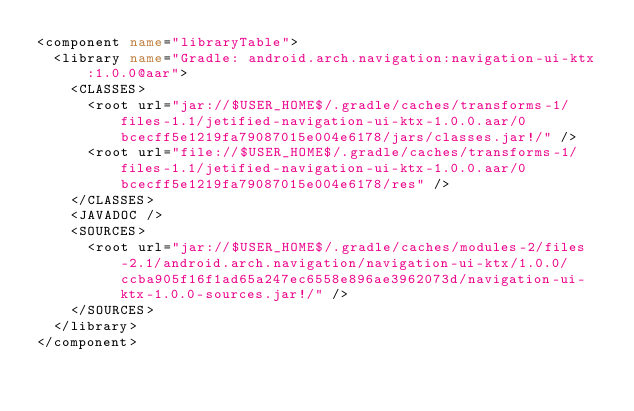<code> <loc_0><loc_0><loc_500><loc_500><_XML_><component name="libraryTable">
  <library name="Gradle: android.arch.navigation:navigation-ui-ktx:1.0.0@aar">
    <CLASSES>
      <root url="jar://$USER_HOME$/.gradle/caches/transforms-1/files-1.1/jetified-navigation-ui-ktx-1.0.0.aar/0bcecff5e1219fa79087015e004e6178/jars/classes.jar!/" />
      <root url="file://$USER_HOME$/.gradle/caches/transforms-1/files-1.1/jetified-navigation-ui-ktx-1.0.0.aar/0bcecff5e1219fa79087015e004e6178/res" />
    </CLASSES>
    <JAVADOC />
    <SOURCES>
      <root url="jar://$USER_HOME$/.gradle/caches/modules-2/files-2.1/android.arch.navigation/navigation-ui-ktx/1.0.0/ccba905f16f1ad65a247ec6558e896ae3962073d/navigation-ui-ktx-1.0.0-sources.jar!/" />
    </SOURCES>
  </library>
</component></code> 